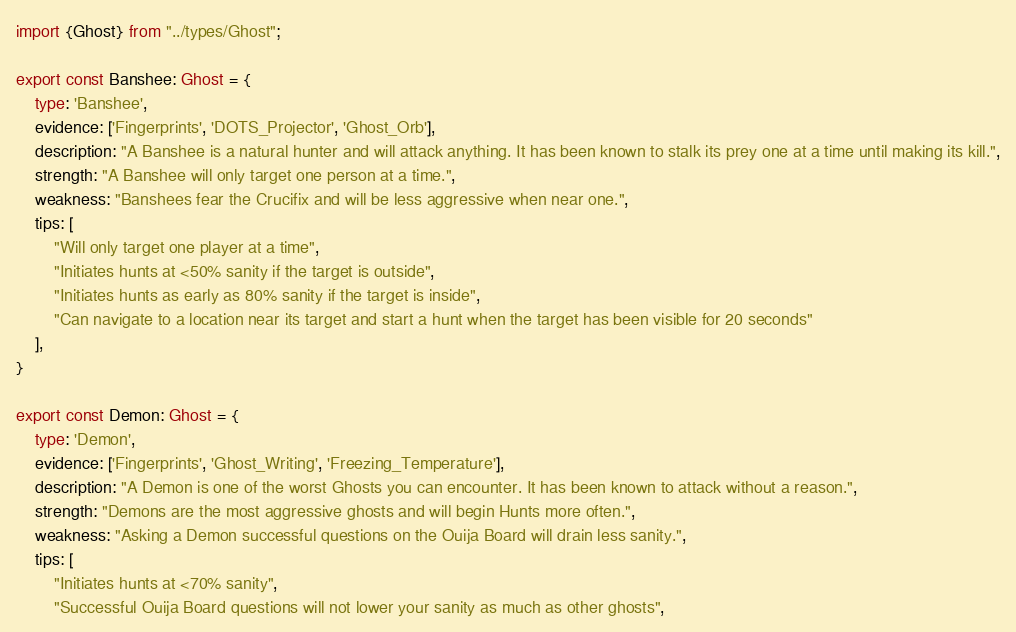Convert code to text. <code><loc_0><loc_0><loc_500><loc_500><_TypeScript_>import {Ghost} from "../types/Ghost";

export const Banshee: Ghost = {
    type: 'Banshee',
    evidence: ['Fingerprints', 'DOTS_Projector', 'Ghost_Orb'],
    description: "A Banshee is a natural hunter and will attack anything. It has been known to stalk its prey one at a time until making its kill.",
    strength: "A Banshee will only target one person at a time.",
    weakness: "Banshees fear the Crucifix and will be less aggressive when near one.",
    tips: [
        "Will only target one player at a time",
        "Initiates hunts at <50% sanity if the target is outside",
        "Initiates hunts as early as 80% sanity if the target is inside",
        "Can navigate to a location near its target and start a hunt when the target has been visible for 20 seconds"
    ],
}

export const Demon: Ghost = {
    type: 'Demon',
    evidence: ['Fingerprints', 'Ghost_Writing', 'Freezing_Temperature'],
    description: "A Demon is one of the worst Ghosts you can encounter. It has been known to attack without a reason.",
    strength: "Demons are the most aggressive ghosts and will begin Hunts more often.",
    weakness: "Asking a Demon successful questions on the Ouija Board will drain less sanity.",
    tips: [
        "Initiates hunts at <70% sanity",
        "Successful Ouija Board questions will not lower your sanity as much as other ghosts",</code> 